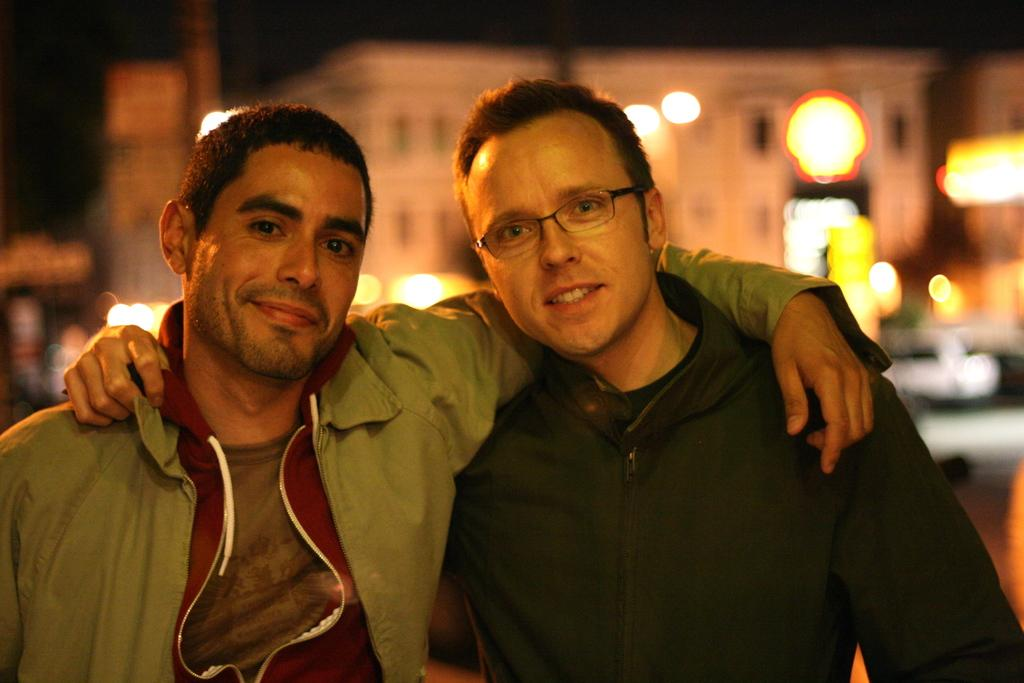How many people are in the image? There are two men in the image. What is the facial expression of the men in the image? The men are smiling. Can you describe the background of the image? The background of the image is blurry. What type of nerve is being discussed by the men in the image? There is no discussion or mention of a nerve in the image; the men are simply smiling. 